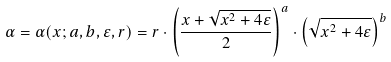<formula> <loc_0><loc_0><loc_500><loc_500>\alpha = \alpha ( x ; a , b , \varepsilon , r ) = r \cdot \left ( \frac { x + \sqrt { x ^ { 2 } + 4 \varepsilon } } { 2 } \right ) ^ { a } \cdot \left ( \sqrt { x ^ { 2 } + 4 \varepsilon } \right ) ^ { b }</formula> 